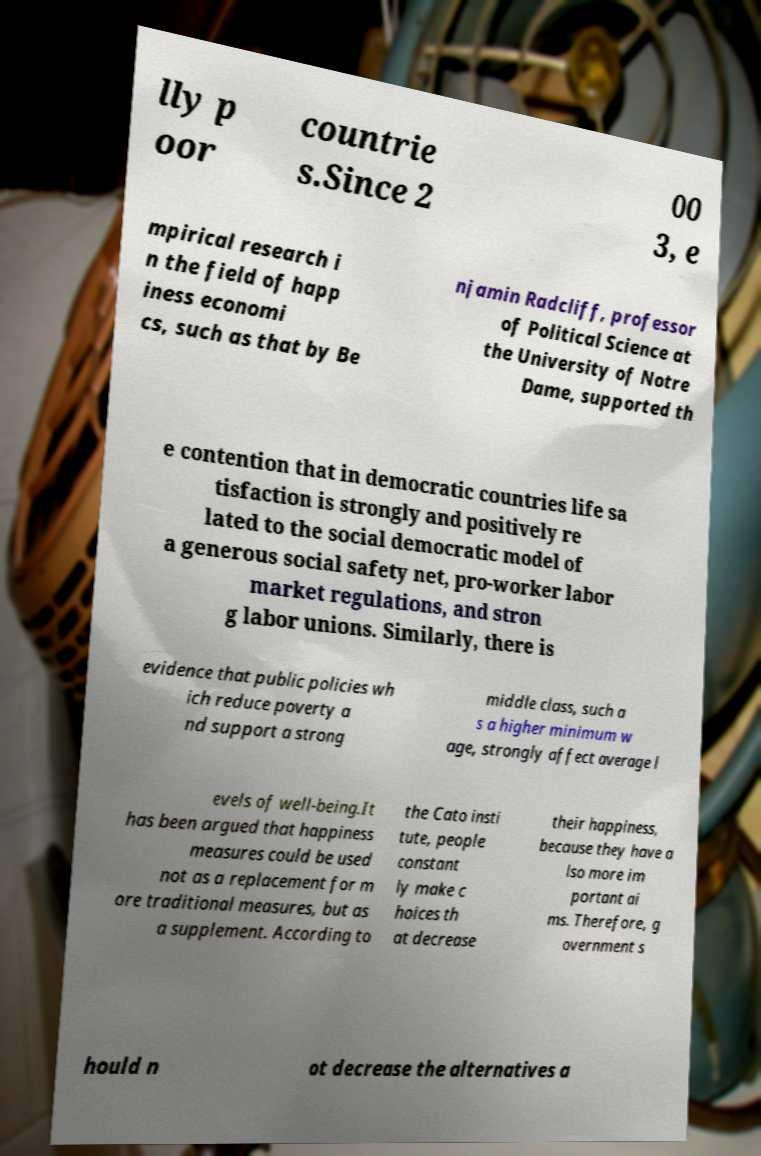Please read and relay the text visible in this image. What does it say? lly p oor countrie s.Since 2 00 3, e mpirical research i n the field of happ iness economi cs, such as that by Be njamin Radcliff, professor of Political Science at the University of Notre Dame, supported th e contention that in democratic countries life sa tisfaction is strongly and positively re lated to the social democratic model of a generous social safety net, pro-worker labor market regulations, and stron g labor unions. Similarly, there is evidence that public policies wh ich reduce poverty a nd support a strong middle class, such a s a higher minimum w age, strongly affect average l evels of well-being.It has been argued that happiness measures could be used not as a replacement for m ore traditional measures, but as a supplement. According to the Cato insti tute, people constant ly make c hoices th at decrease their happiness, because they have a lso more im portant ai ms. Therefore, g overnment s hould n ot decrease the alternatives a 